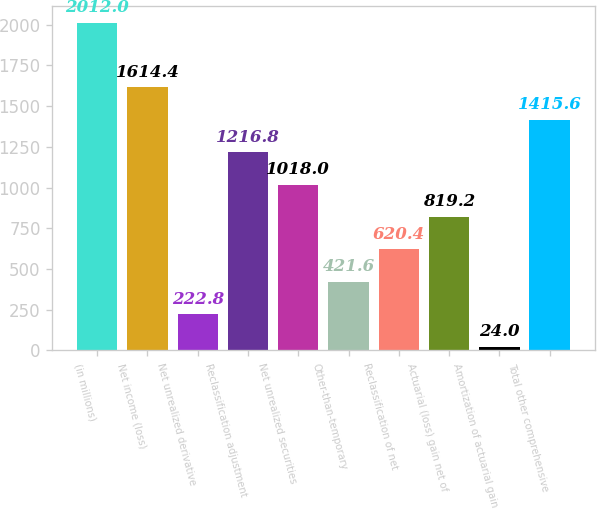Convert chart to OTSL. <chart><loc_0><loc_0><loc_500><loc_500><bar_chart><fcel>(in millions)<fcel>Net income (loss)<fcel>Net unrealized derivative<fcel>Reclassification adjustment<fcel>Net unrealized securities<fcel>Other-than-temporary<fcel>Reclassification of net<fcel>Actuarial (loss) gain net of<fcel>Amortization of actuarial gain<fcel>Total other comprehensive<nl><fcel>2012<fcel>1614.4<fcel>222.8<fcel>1216.8<fcel>1018<fcel>421.6<fcel>620.4<fcel>819.2<fcel>24<fcel>1415.6<nl></chart> 